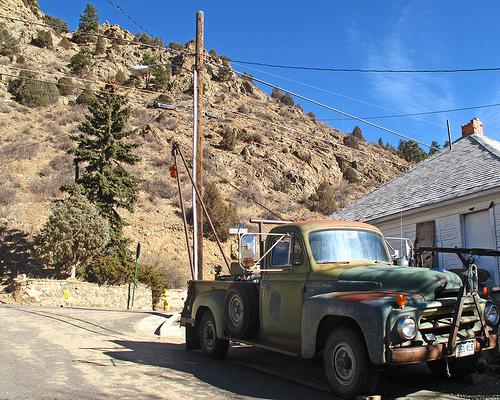Describe the surrounding landscape and environment in this picture. The image shows elevated terrain with a rocky hillside and trees in the background, a cobblestone wall by the road, and a dirt patch on the road. What can be found on the foreground of the image? In the foreground, there's a truck parked on the road beside an older white house and a cobblestone wall near a dirty road. How many trees can be seen in this image and what is their appearance? There is one small tree on land, in the middle of the elevated terrain with trees on a mountain in the background. List any objects related to transportation or traffic found in the image. Truck, front and rear tires, license plate, headlights, a stop sign, and a green street sign. Can you see any clouds in the sky? If so, describe them. Yes, there are several white clouds dispersed across the blue sky, varying in size and shape. Mention any vehicle equipment that exists in the image, and where it can be found. The truck is equipped with towing equipment and a spare tire attached to the side of the truck. Describe anything unusual or unique about the truck in the image. The truck is old, green, and has dirty windshield, and it is equipped with towing equipment and a spare tire on its side. What vehicle can be found in the image, and where is it parked? An old truck is parked on the side of the road near a white house with a gray roof. Identify any notable features of the house in the image. The house is an older white house with a gray roof, a chimney, and it's located beside the parked truck. What is the overall sentiment of the image based on its contents and surroundings? The image conveys a somewhat nostalgic and rural sentiment, featuring an old truck, a white house, and natural elements like hills and trees in the background. 